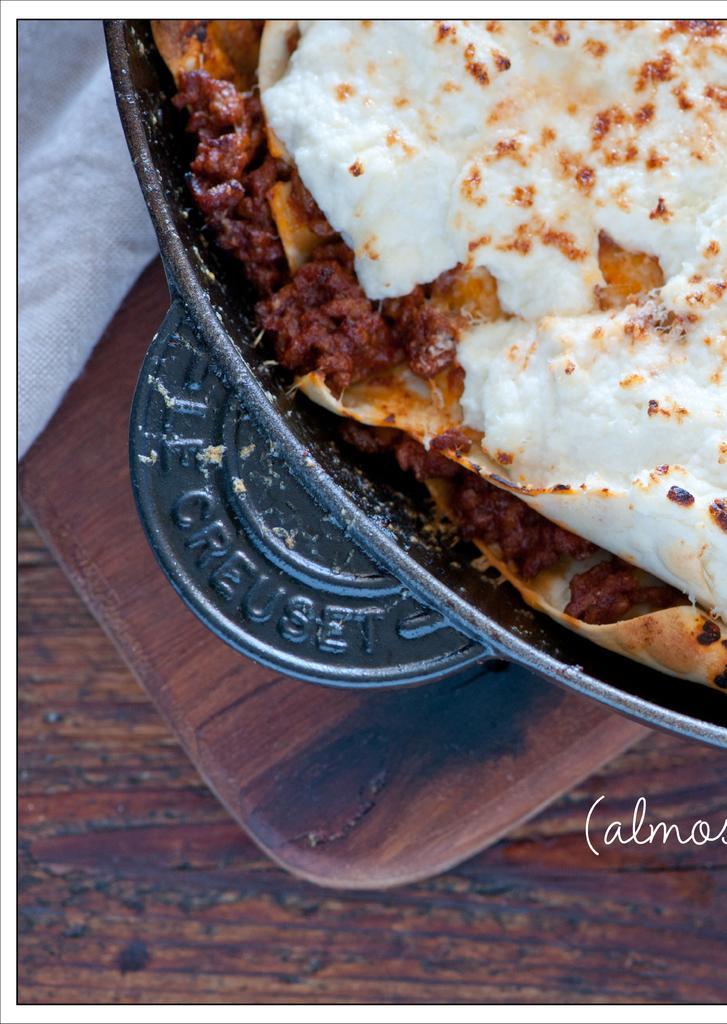Please provide a concise description of this image. In this image I can see food in the plate. Food is in white,brown and red color. The plate is on the brown surface. 